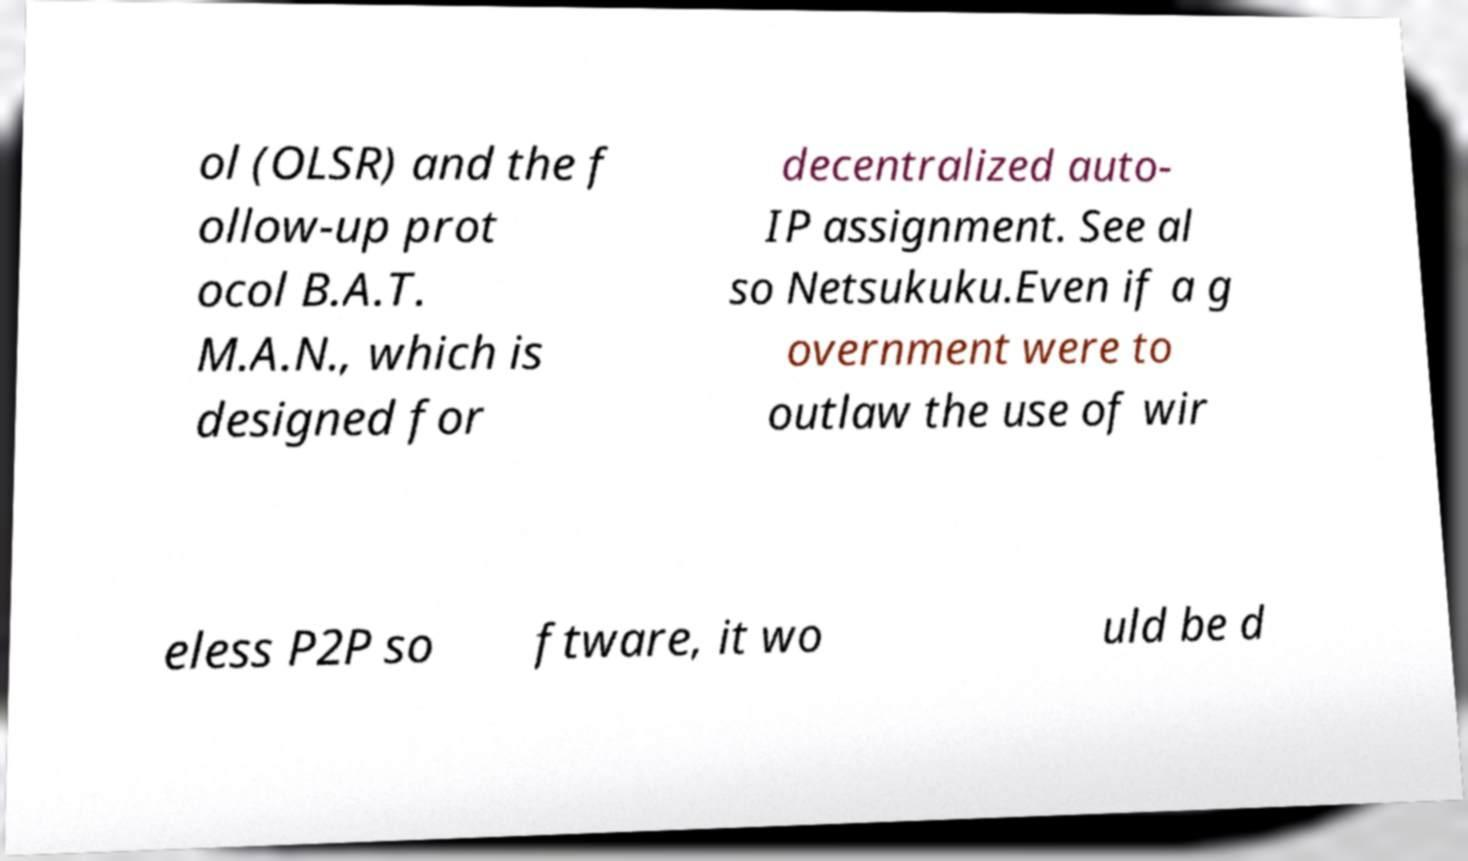Please identify and transcribe the text found in this image. ol (OLSR) and the f ollow-up prot ocol B.A.T. M.A.N., which is designed for decentralized auto- IP assignment. See al so Netsukuku.Even if a g overnment were to outlaw the use of wir eless P2P so ftware, it wo uld be d 